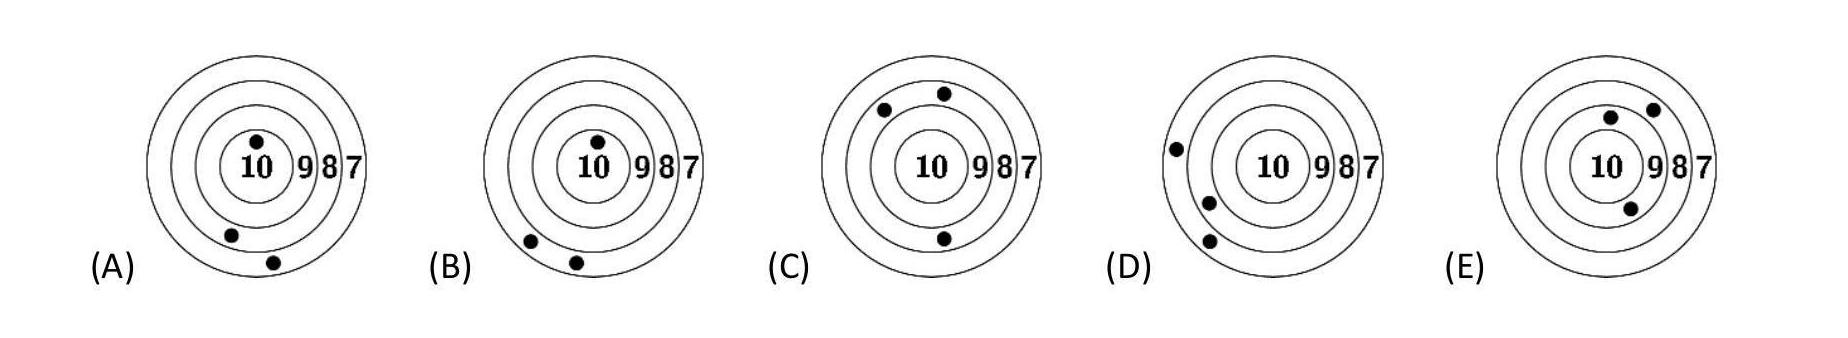Can you discuss how we can deduce the capabilities of each participant from the image? By analyzing each target, you can estimate the accuracy and consistency of the shooters. Targets with more central hits demonstrate greater precision, as seen in target 'E', suggesting higher skill and steadiness. Which target shows the potential for improvement and why? Target 'A' shows potential for improvement, as the shots are spread widely across the target, indicating the need for more consistent aiming techniques. 